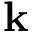<formula> <loc_0><loc_0><loc_500><loc_500>k</formula> 